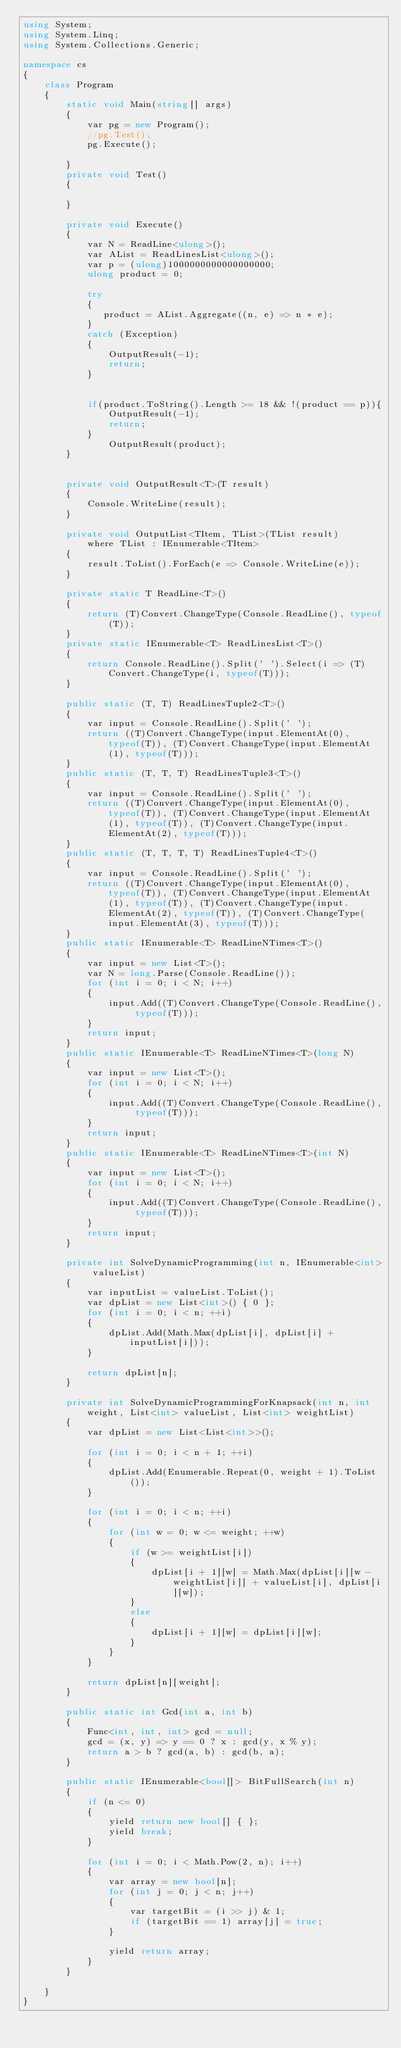<code> <loc_0><loc_0><loc_500><loc_500><_C#_>using System;
using System.Linq;
using System.Collections.Generic;

namespace cs
{
    class Program
    {
        static void Main(string[] args)
        {
            var pg = new Program();
            //pg.Test();
            pg.Execute();

        }
        private void Test()
        {

        }

        private void Execute()
        {
            var N = ReadLine<ulong>();
            var AList = ReadLinesList<ulong>();
            var p = (ulong)1000000000000000000;
            ulong product = 0;

            try
            {
               product = AList.Aggregate((n, e) => n * e);
            }
            catch (Exception)
            {
                OutputResult(-1);
                return;
            }
            

            if(product.ToString().Length >= 18 && !(product == p)){
                OutputResult(-1);
                return;
            }
                OutputResult(product);
        }


        private void OutputResult<T>(T result)
        {
            Console.WriteLine(result);
        }

        private void OutputList<TItem, TList>(TList result)
            where TList : IEnumerable<TItem>
        {
            result.ToList().ForEach(e => Console.WriteLine(e));
        }

        private static T ReadLine<T>()
        {
            return (T)Convert.ChangeType(Console.ReadLine(), typeof(T));
        }
        private static IEnumerable<T> ReadLinesList<T>()
        {
            return Console.ReadLine().Split(' ').Select(i => (T)Convert.ChangeType(i, typeof(T)));
        }

        public static (T, T) ReadLinesTuple2<T>()
        {
            var input = Console.ReadLine().Split(' ');
            return ((T)Convert.ChangeType(input.ElementAt(0), typeof(T)), (T)Convert.ChangeType(input.ElementAt(1), typeof(T)));
        }
        public static (T, T, T) ReadLinesTuple3<T>()
        {
            var input = Console.ReadLine().Split(' ');
            return ((T)Convert.ChangeType(input.ElementAt(0), typeof(T)), (T)Convert.ChangeType(input.ElementAt(1), typeof(T)), (T)Convert.ChangeType(input.ElementAt(2), typeof(T)));
        }
        public static (T, T, T, T) ReadLinesTuple4<T>()
        {
            var input = Console.ReadLine().Split(' ');
            return ((T)Convert.ChangeType(input.ElementAt(0), typeof(T)), (T)Convert.ChangeType(input.ElementAt(1), typeof(T)), (T)Convert.ChangeType(input.ElementAt(2), typeof(T)), (T)Convert.ChangeType(input.ElementAt(3), typeof(T)));
        }
        public static IEnumerable<T> ReadLineNTimes<T>()
        {
            var input = new List<T>();
            var N = long.Parse(Console.ReadLine());
            for (int i = 0; i < N; i++)
            {
                input.Add((T)Convert.ChangeType(Console.ReadLine(), typeof(T)));
            }
            return input;
        }
        public static IEnumerable<T> ReadLineNTimes<T>(long N)
        {
            var input = new List<T>();
            for (int i = 0; i < N; i++)
            {
                input.Add((T)Convert.ChangeType(Console.ReadLine(), typeof(T)));
            }
            return input;
        }
        public static IEnumerable<T> ReadLineNTimes<T>(int N)
        {
            var input = new List<T>();
            for (int i = 0; i < N; i++)
            {
                input.Add((T)Convert.ChangeType(Console.ReadLine(), typeof(T)));
            }
            return input;
        }

        private int SolveDynamicProgramming(int n, IEnumerable<int> valueList)
        {
            var inputList = valueList.ToList();
            var dpList = new List<int>() { 0 };
            for (int i = 0; i < n; ++i)
            {
                dpList.Add(Math.Max(dpList[i], dpList[i] + inputList[i]));
            }

            return dpList[n];
        }

        private int SolveDynamicProgrammingForKnapsack(int n, int weight, List<int> valueList, List<int> weightList)
        {
            var dpList = new List<List<int>>();

            for (int i = 0; i < n + 1; ++i)
            {
                dpList.Add(Enumerable.Repeat(0, weight + 1).ToList());
            }

            for (int i = 0; i < n; ++i)
            {
                for (int w = 0; w <= weight; ++w)
                {
                    if (w >= weightList[i])
                    {
                        dpList[i + 1][w] = Math.Max(dpList[i][w - weightList[i]] + valueList[i], dpList[i][w]);
                    }
                    else
                    {
                        dpList[i + 1][w] = dpList[i][w];
                    }
                }
            }

            return dpList[n][weight];
        }

        public static int Gcd(int a, int b)
        {
            Func<int, int, int> gcd = null;
            gcd = (x, y) => y == 0 ? x : gcd(y, x % y);
            return a > b ? gcd(a, b) : gcd(b, a);
        }

        public static IEnumerable<bool[]> BitFullSearch(int n)
        {
            if (n <= 0)
            {
                yield return new bool[] { };
                yield break;
            }

            for (int i = 0; i < Math.Pow(2, n); i++)
            {
                var array = new bool[n];
                for (int j = 0; j < n; j++)
                {
                    var targetBit = (i >> j) & 1;
                    if (targetBit == 1) array[j] = true;
                }

                yield return array;
            }
        }

    }
}
</code> 